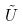Convert formula to latex. <formula><loc_0><loc_0><loc_500><loc_500>\tilde { U }</formula> 